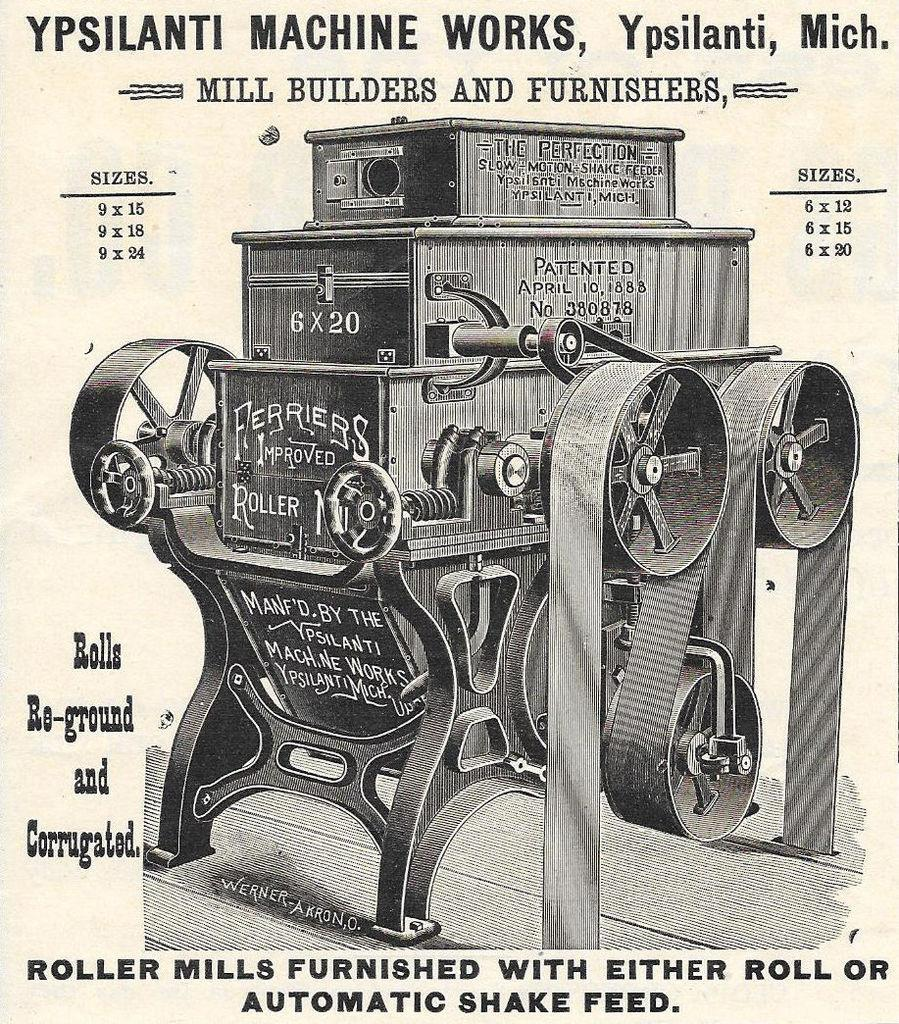What type of artwork is the image? The image is a painting. What is the main subject of the painting? There is an engine depicted in the painting. Is there any text present in the painting? Yes, there is text at the bottom and top of the painting. How many babies are depicted in the painting? There are no babies depicted in the painting; it features an engine and text. What organization is responsible for creating the painting? The facts provided do not mention any organization responsible for creating the painting. 